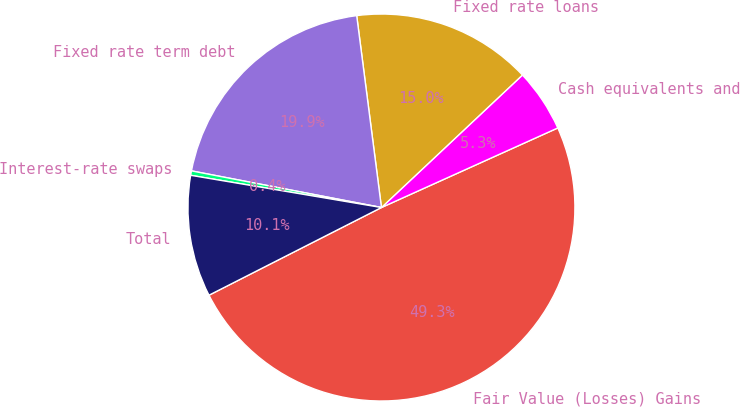Convert chart to OTSL. <chart><loc_0><loc_0><loc_500><loc_500><pie_chart><fcel>Fair Value (Losses) Gains<fcel>Cash equivalents and<fcel>Fixed rate loans<fcel>Fixed rate term debt<fcel>Interest-rate swaps<fcel>Total<nl><fcel>49.27%<fcel>5.26%<fcel>15.04%<fcel>19.93%<fcel>0.37%<fcel>10.15%<nl></chart> 